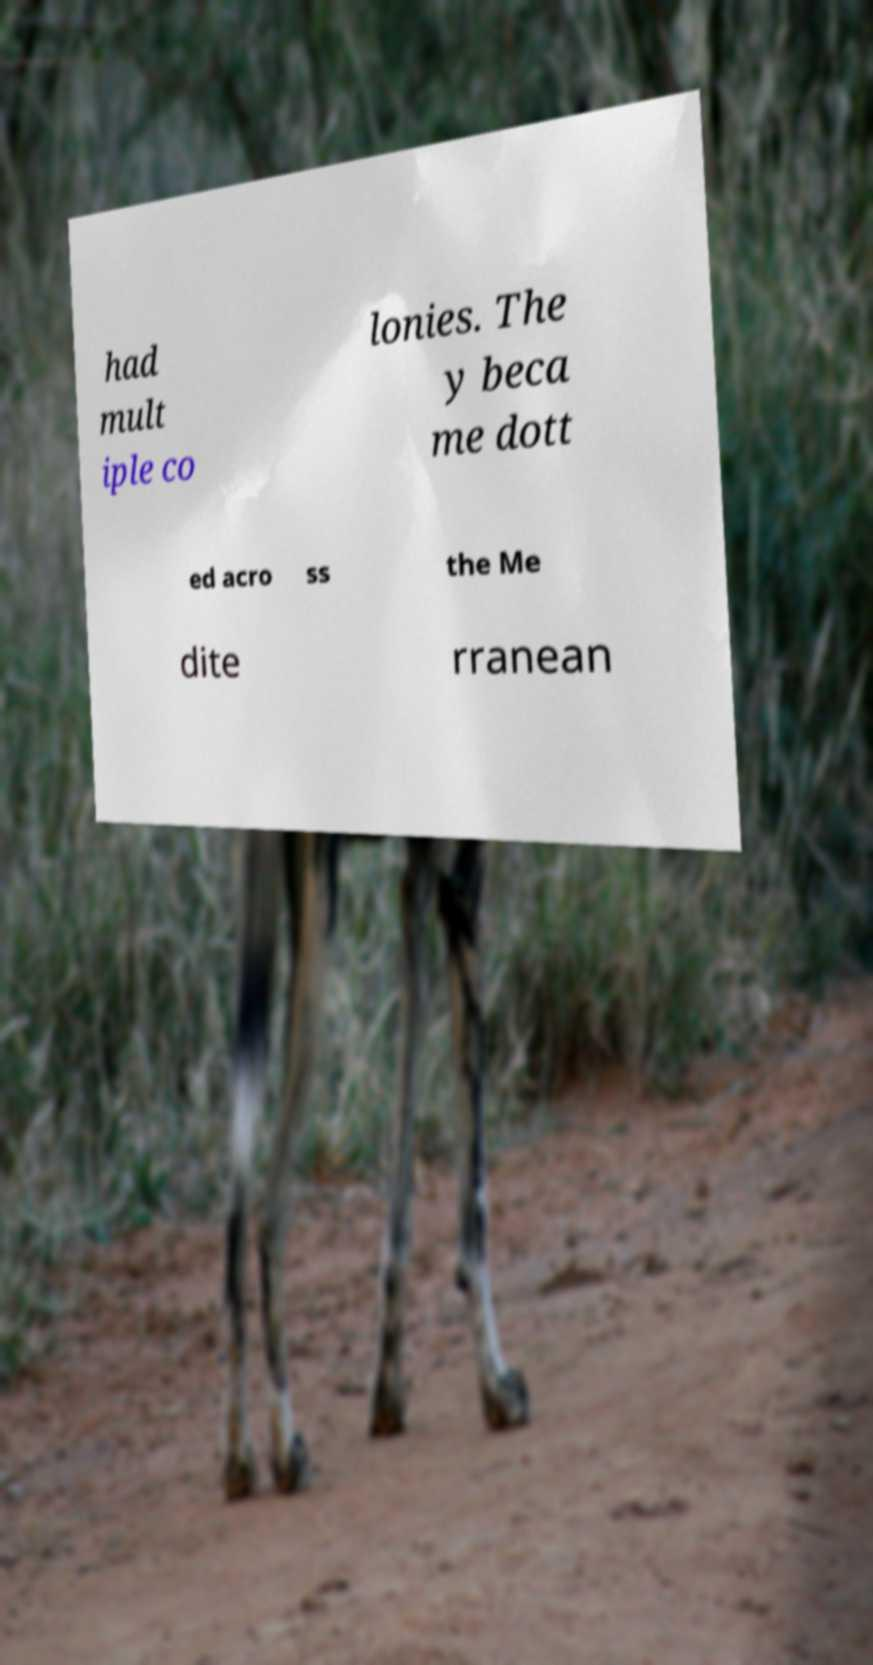Can you read and provide the text displayed in the image?This photo seems to have some interesting text. Can you extract and type it out for me? had mult iple co lonies. The y beca me dott ed acro ss the Me dite rranean 